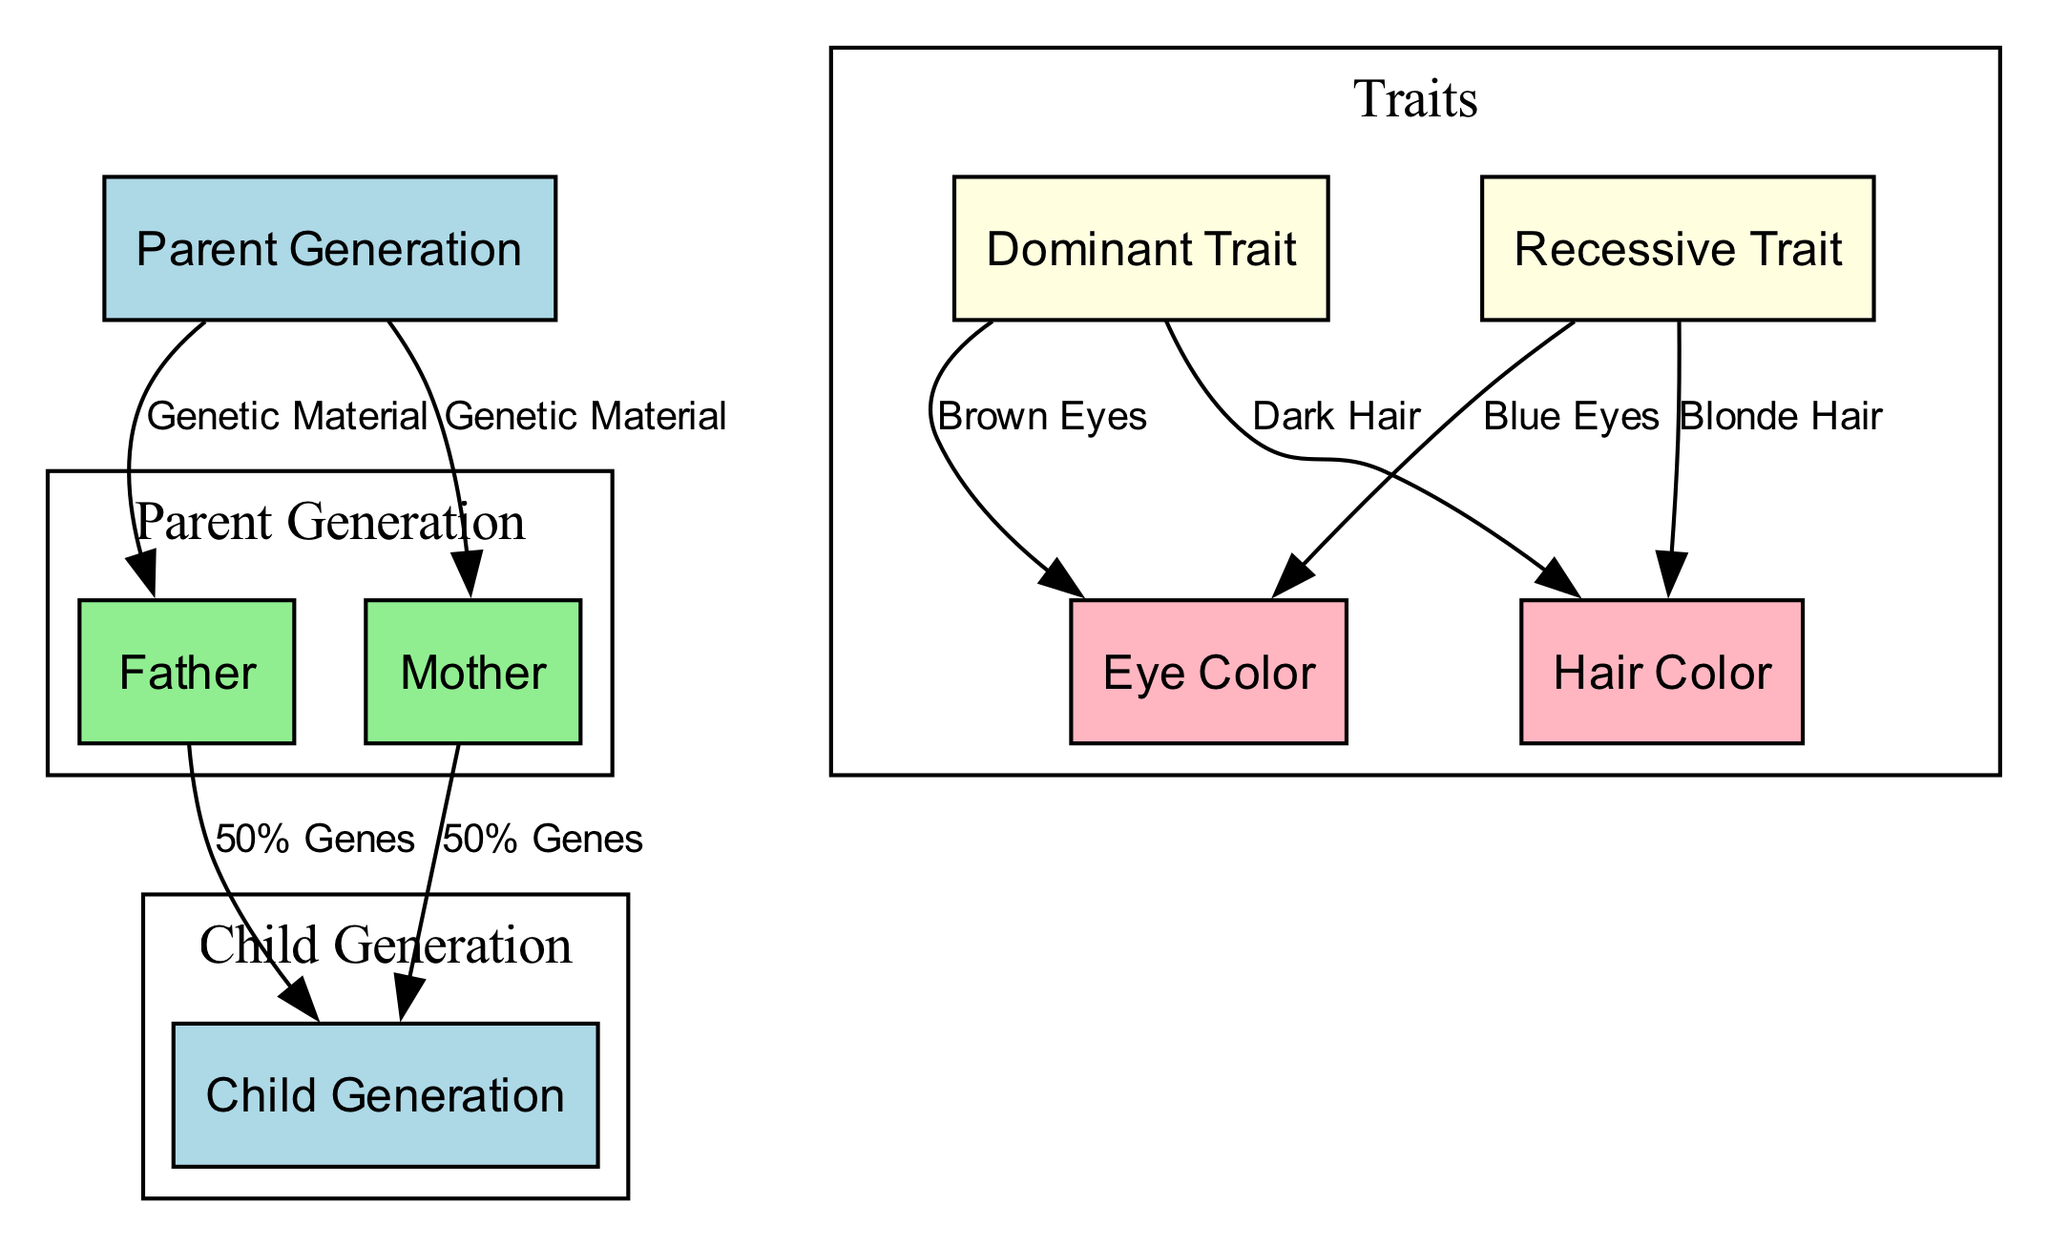What is the label of the first node? The first node has the label "Parent Generation", which is directly stated in the diagram.
Answer: Parent Generation How many total nodes are in the diagram? Counting all the distinct nodes listed, we have eight nodes: Parent Generation, Father, Mother, Child Generation, Dominant Trait, Recessive Trait, Eye Color, and Hair Color.
Answer: 8 What connection type exists between the Father and Child Generation? There is a connection labeled "50% Genes" from the Father to the Child Generation, indicating the genetic contribution.
Answer: 50% Genes Which trait is related to Brown Eyes? The Dominant Trait is linked to Eye Color, specifically leading to the outcome of Brown Eyes in the diagram.
Answer: Brown Eyes How is Blue Eyes categorized in the diagram? Blue Eyes stems from the connection of Recessive Trait to Eye Color, indicating its classification as a recessive trait.
Answer: Recessive Trait What is the edge label connecting the Parent Generation to the Father? The edge label indicating the connection from the Parent Generation to the Father is "Genetic Material", specifying the genetic link.
Answer: Genetic Material What generation does the node labeled "Child Generation" belong to? The node labeled "Child Generation" is derived from the first generation, which contains both parents contributing to the child's genetic makeup.
Answer: Child Generation What color of Hair corresponds to the Dominant Trait? The Dominant Trait leads to the outcome of Dark Hair according to the labeled connections in the diagram.
Answer: Dark Hair How does the Recessive Trait affect Hair Color? The diagram indicates that the Recessive Trait is associated with Blonde Hair, showcasing a designated genetic trait outcome.
Answer: Blonde Hair Which color eyes are associated with the Recessive Trait? The Recessive Trait is specifically linked to Blue Eyes in the genetic inheritance flow depicted in the diagram.
Answer: Blue Eyes 